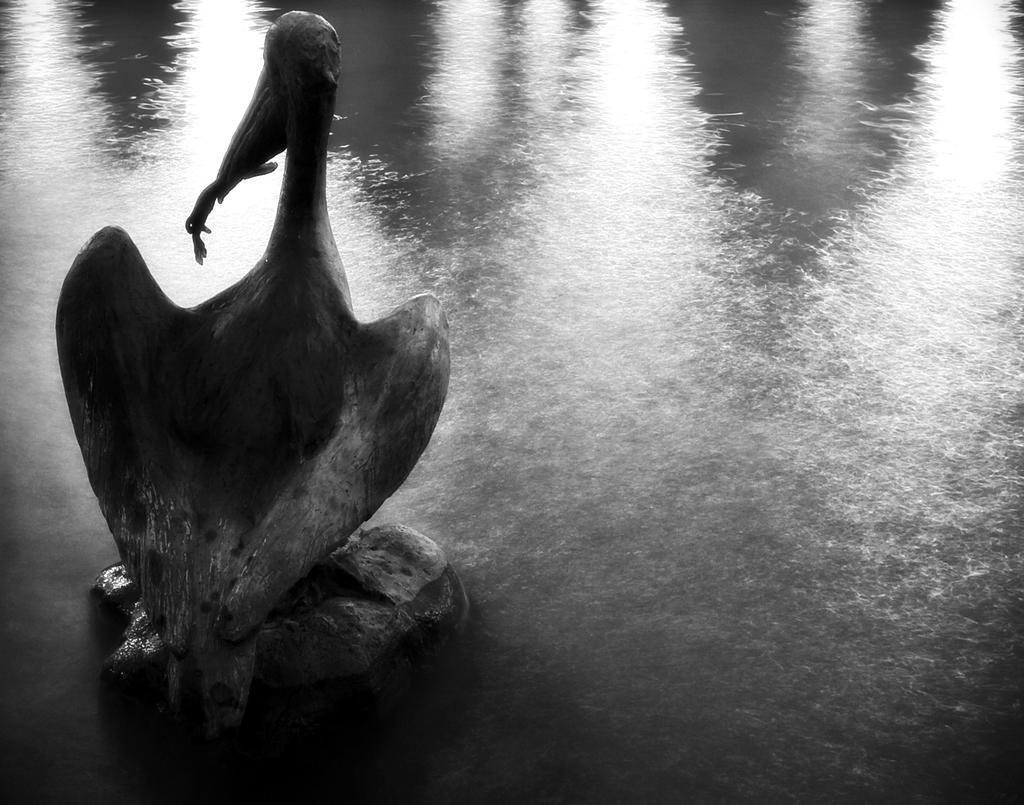What type of animal can be seen in the image? There is a bird in the image. Where is the bird located? The bird is on a stone in the image. What is the bird doing in the image? The bird has an insect in its mouth. What can be seen in the background of the image? There is a water body in the image. How many dimes are floating on the water body in the image? There are no dimes visible in the image; it only features a bird, a stone, and a water body. 